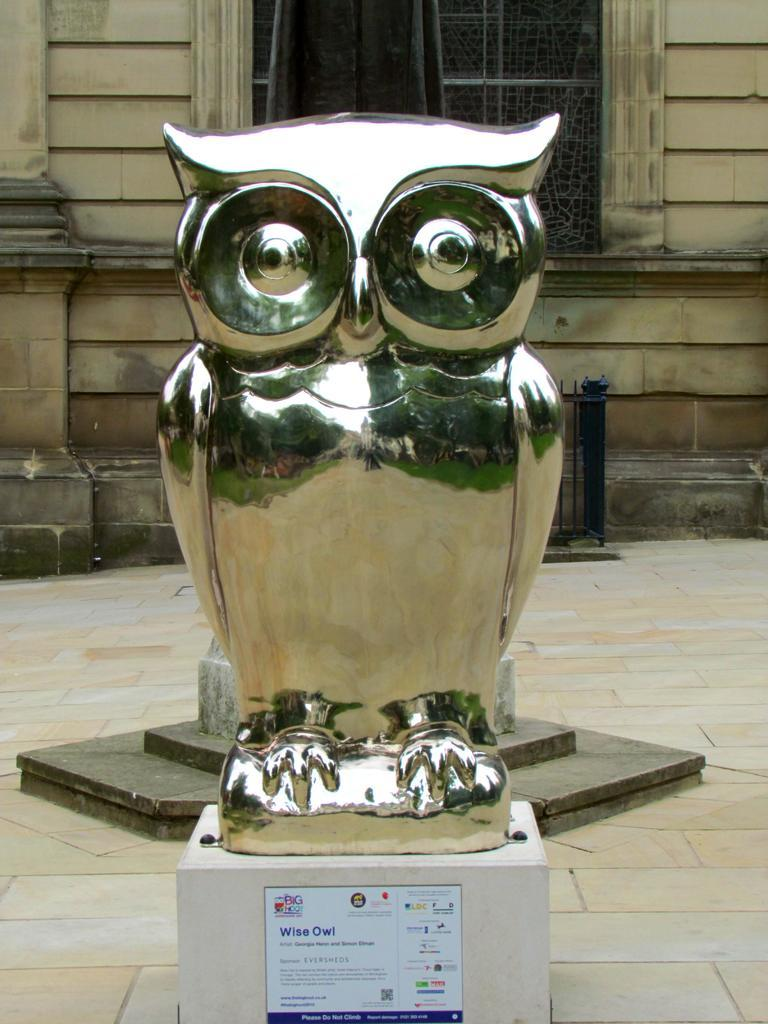What is the main subject in the image? There is a statue in the image. What is the color of the statue? The statue is silver in color. What can be seen in the background of the image? There is a building in the background of the image. What is the color of the building? The building is brown in color. Can you identify any architectural features in the image? Yes, there is a window visible in the image. What type of bridge can be seen connecting the statue to the building in the image? There is no bridge present in the image; it only features a statue and a building in the background. 